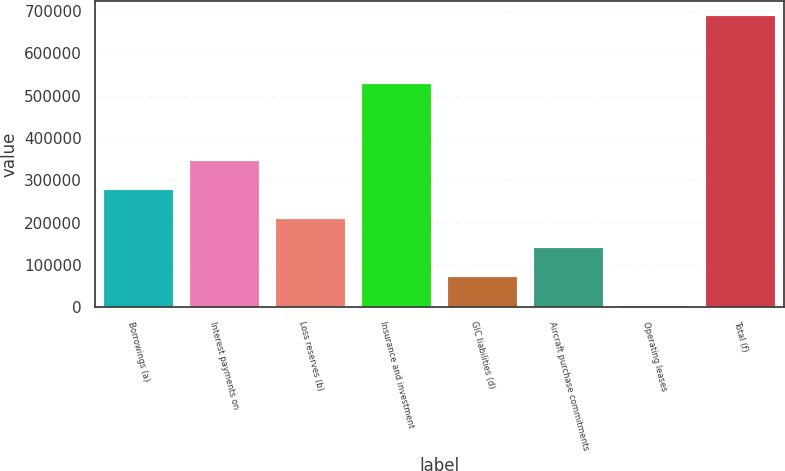Convert chart. <chart><loc_0><loc_0><loc_500><loc_500><bar_chart><fcel>Borrowings (a)<fcel>Interest payments on<fcel>Loss reserves (b)<fcel>Insurance and investment<fcel>GIC liabilities (d)<fcel>Aircraft purchase commitments<fcel>Operating leases<fcel>Total (f)<nl><fcel>276654<fcel>345332<fcel>207977<fcel>528174<fcel>70622.3<fcel>139300<fcel>1945<fcel>688718<nl></chart> 